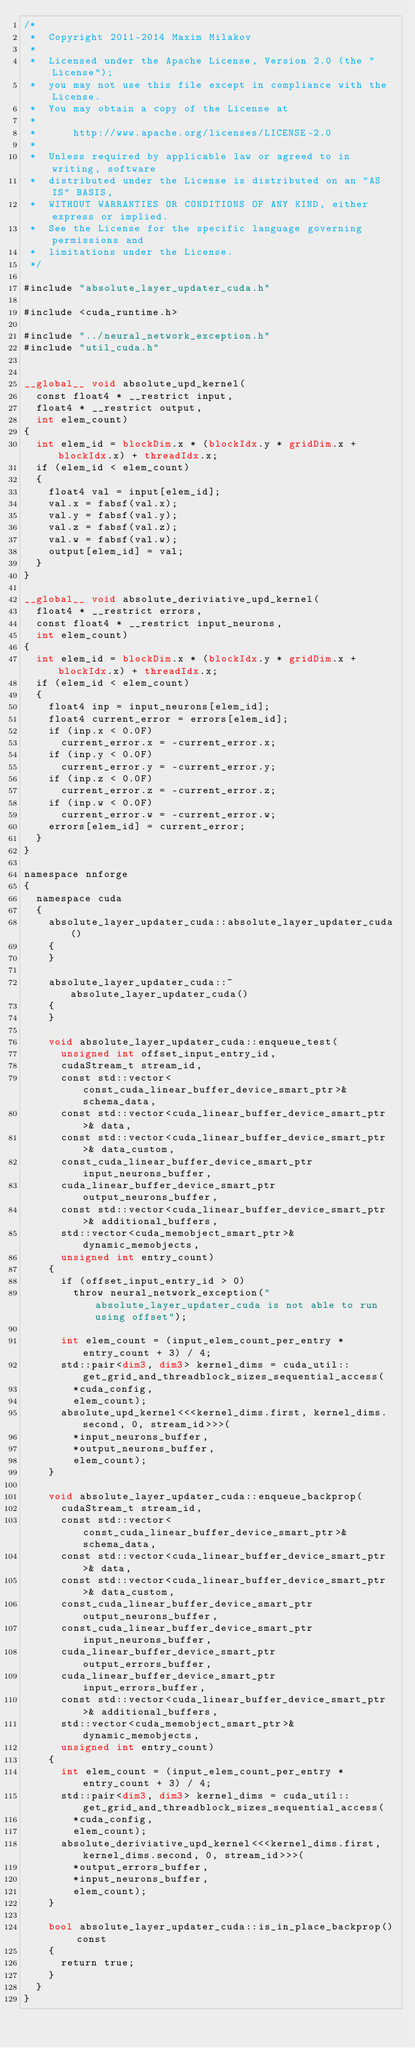<code> <loc_0><loc_0><loc_500><loc_500><_Cuda_>/*
 *  Copyright 2011-2014 Maxim Milakov
 *
 *  Licensed under the Apache License, Version 2.0 (the "License");
 *  you may not use this file except in compliance with the License.
 *  You may obtain a copy of the License at
 *
 *      http://www.apache.org/licenses/LICENSE-2.0
 *
 *  Unless required by applicable law or agreed to in writing, software
 *  distributed under the License is distributed on an "AS IS" BASIS,
 *  WITHOUT WARRANTIES OR CONDITIONS OF ANY KIND, either express or implied.
 *  See the License for the specific language governing permissions and
 *  limitations under the License.
 */

#include "absolute_layer_updater_cuda.h"

#include <cuda_runtime.h>

#include "../neural_network_exception.h"
#include "util_cuda.h"


__global__ void absolute_upd_kernel(
	const float4 * __restrict input,
	float4 * __restrict output,
	int elem_count)
{
	int elem_id = blockDim.x * (blockIdx.y * gridDim.x + blockIdx.x) + threadIdx.x;
	if (elem_id < elem_count)
	{
		float4 val = input[elem_id];
		val.x = fabsf(val.x);
		val.y = fabsf(val.y);
		val.z = fabsf(val.z);
		val.w = fabsf(val.w);
		output[elem_id] = val;
	}
}

__global__ void absolute_deriviative_upd_kernel(
	float4 * __restrict errors,
	const float4 * __restrict input_neurons,
	int elem_count)
{
	int elem_id = blockDim.x * (blockIdx.y * gridDim.x + blockIdx.x) + threadIdx.x;
	if (elem_id < elem_count)
	{
		float4 inp = input_neurons[elem_id];
		float4 current_error = errors[elem_id];
		if (inp.x < 0.0F)
			current_error.x = -current_error.x;
		if (inp.y < 0.0F)
			current_error.y = -current_error.y;
		if (inp.z < 0.0F)
			current_error.z = -current_error.z;
		if (inp.w < 0.0F)
			current_error.w = -current_error.w;
		errors[elem_id] = current_error;
	}
}

namespace nnforge
{
	namespace cuda
	{
		absolute_layer_updater_cuda::absolute_layer_updater_cuda()
		{
		}

		absolute_layer_updater_cuda::~absolute_layer_updater_cuda()
		{
		}

		void absolute_layer_updater_cuda::enqueue_test(
			unsigned int offset_input_entry_id,
			cudaStream_t stream_id,
			const std::vector<const_cuda_linear_buffer_device_smart_ptr>& schema_data,
			const std::vector<cuda_linear_buffer_device_smart_ptr>& data,
			const std::vector<cuda_linear_buffer_device_smart_ptr>& data_custom,
			const_cuda_linear_buffer_device_smart_ptr input_neurons_buffer,
			cuda_linear_buffer_device_smart_ptr output_neurons_buffer,
			const std::vector<cuda_linear_buffer_device_smart_ptr>& additional_buffers,
			std::vector<cuda_memobject_smart_ptr>& dynamic_memobjects,
			unsigned int entry_count)
		{
			if (offset_input_entry_id > 0)
				throw neural_network_exception("absolute_layer_updater_cuda is not able to run using offset");

			int elem_count = (input_elem_count_per_entry * entry_count + 3) / 4;
			std::pair<dim3, dim3> kernel_dims = cuda_util::get_grid_and_threadblock_sizes_sequential_access(
				*cuda_config,
				elem_count);
			absolute_upd_kernel<<<kernel_dims.first, kernel_dims.second, 0, stream_id>>>(
				*input_neurons_buffer,
				*output_neurons_buffer,
				elem_count);
		}

		void absolute_layer_updater_cuda::enqueue_backprop(
			cudaStream_t stream_id,
			const std::vector<const_cuda_linear_buffer_device_smart_ptr>& schema_data,
			const std::vector<cuda_linear_buffer_device_smart_ptr>& data,
			const std::vector<cuda_linear_buffer_device_smart_ptr>& data_custom,
			const_cuda_linear_buffer_device_smart_ptr output_neurons_buffer,
			const_cuda_linear_buffer_device_smart_ptr input_neurons_buffer,
			cuda_linear_buffer_device_smart_ptr output_errors_buffer,
			cuda_linear_buffer_device_smart_ptr input_errors_buffer,
			const std::vector<cuda_linear_buffer_device_smart_ptr>& additional_buffers,
			std::vector<cuda_memobject_smart_ptr>& dynamic_memobjects,
			unsigned int entry_count)
		{
			int elem_count = (input_elem_count_per_entry * entry_count + 3) / 4;
			std::pair<dim3, dim3> kernel_dims = cuda_util::get_grid_and_threadblock_sizes_sequential_access(
				*cuda_config,
				elem_count);
			absolute_deriviative_upd_kernel<<<kernel_dims.first, kernel_dims.second, 0, stream_id>>>(
				*output_errors_buffer,
				*input_neurons_buffer,
				elem_count);
		}

		bool absolute_layer_updater_cuda::is_in_place_backprop() const
		{
			return true;
		}
	}
}
</code> 